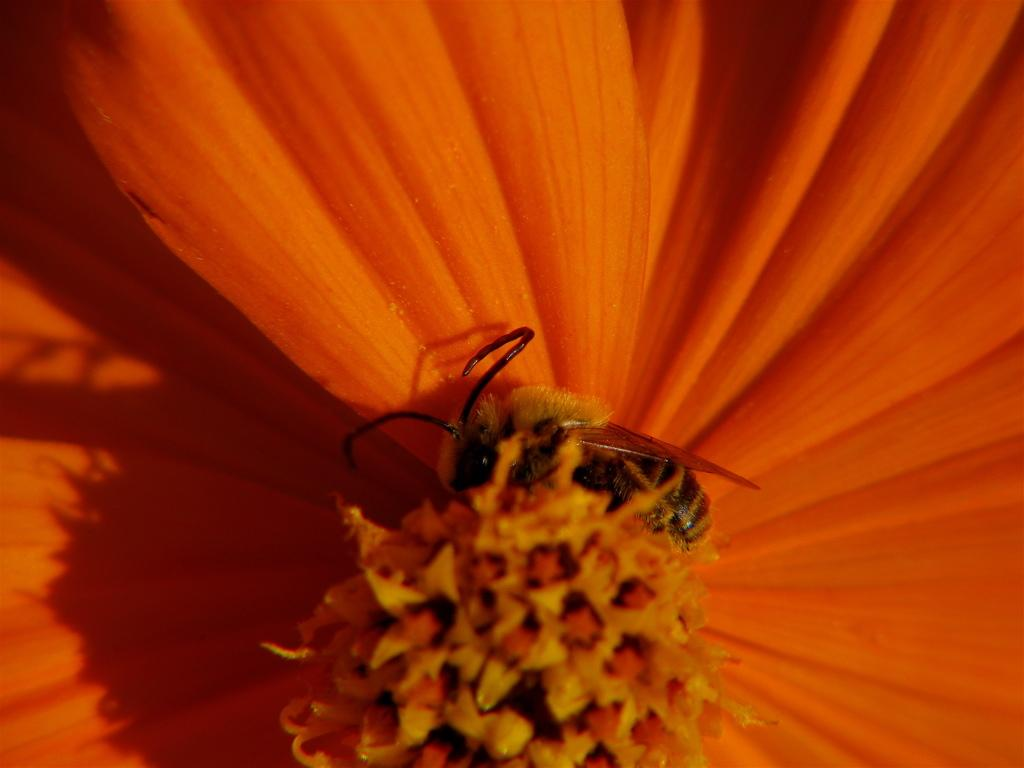What is the main subject of the image? The main subject of the image is a flower. Can you describe the flower in the image? The image is a zoomed in picture of a flower. Are there any other living organisms visible in the image? Yes, there is an insect visible in the image. What type of horse is wearing a mask in the image? There is no horse or mask present in the image; it features a zoomed in picture of a flower with an insect visible. 